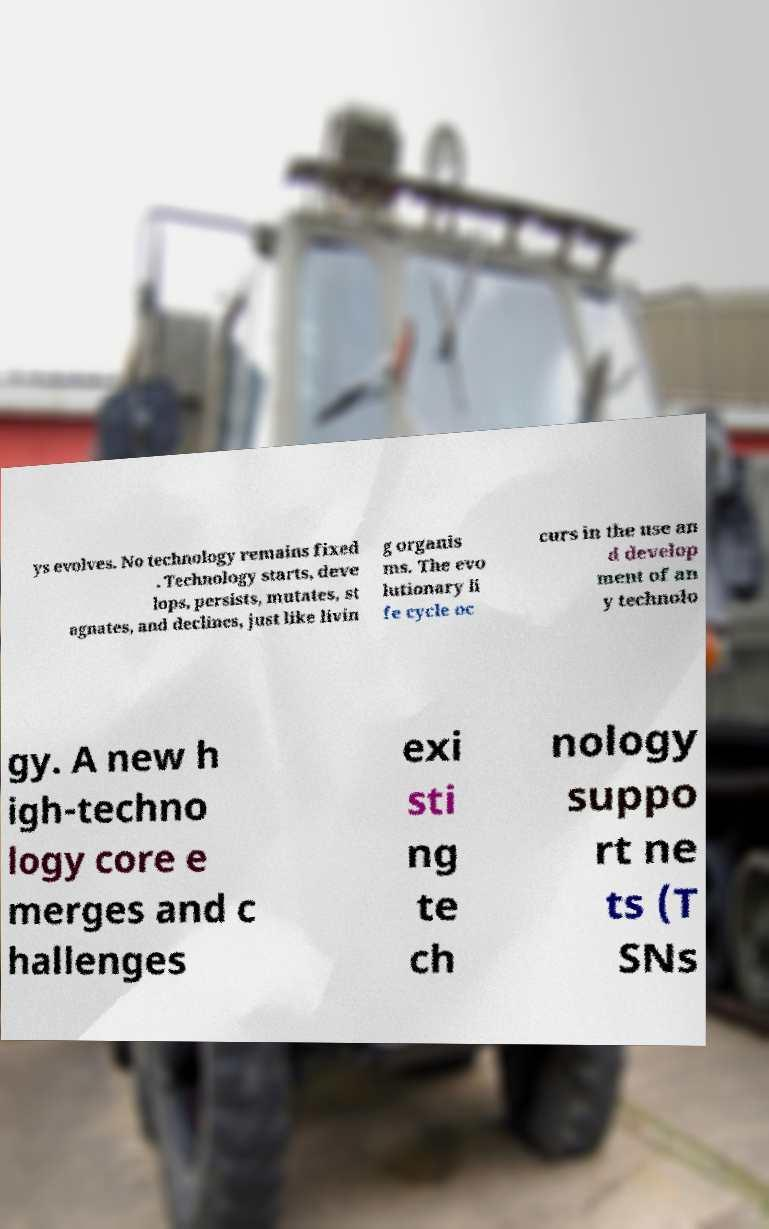Could you extract and type out the text from this image? ys evolves. No technology remains fixed . Technology starts, deve lops, persists, mutates, st agnates, and declines, just like livin g organis ms. The evo lutionary li fe cycle oc curs in the use an d develop ment of an y technolo gy. A new h igh-techno logy core e merges and c hallenges exi sti ng te ch nology suppo rt ne ts (T SNs 